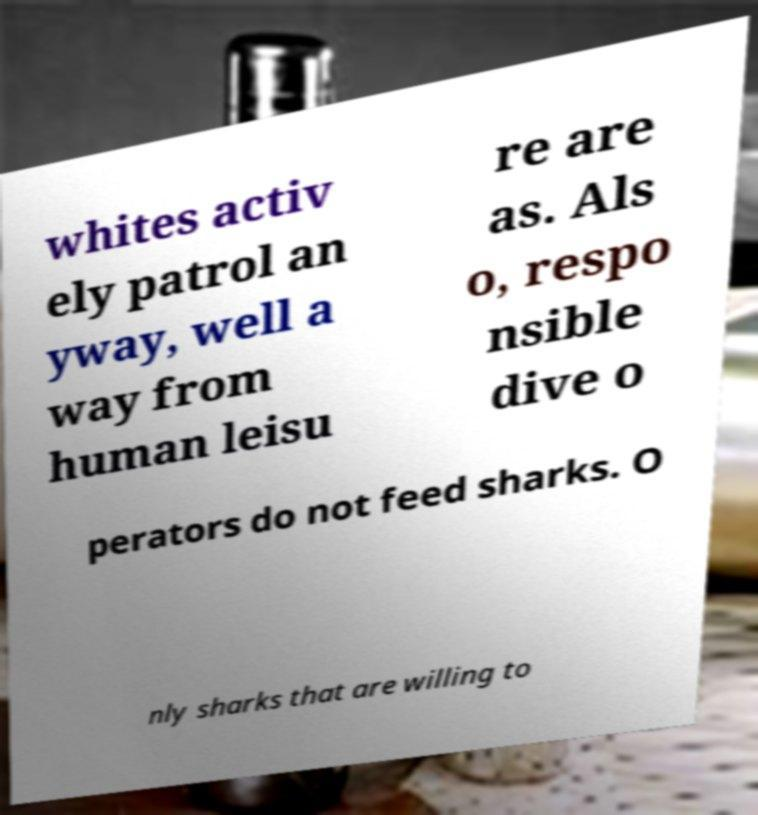Could you extract and type out the text from this image? whites activ ely patrol an yway, well a way from human leisu re are as. Als o, respo nsible dive o perators do not feed sharks. O nly sharks that are willing to 